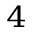<formula> <loc_0><loc_0><loc_500><loc_500>_ { 4 }</formula> 